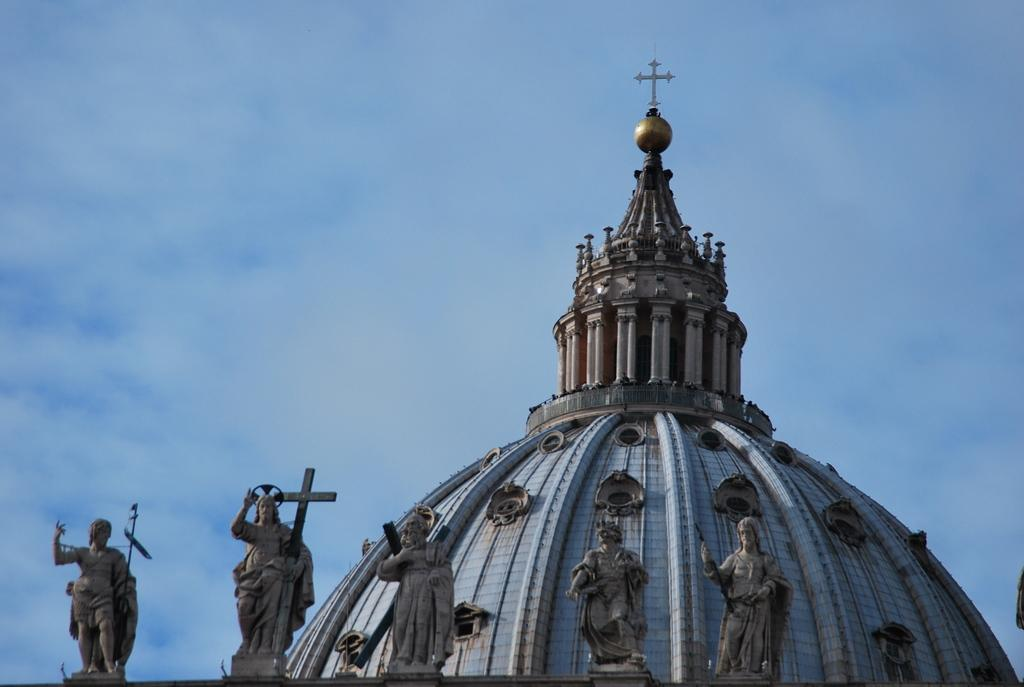What is the main subject of the image? The image shows the top of a building. What architectural features can be seen on the building? The building has pillars. Are there any decorative elements on the building? Yes, there are statues in the image. What can be seen in the background of the image? The sky is visible in the background. What is the weather like in the image? Clouds are present in the sky, suggesting a partly cloudy day. What type of pan is being used by the governor in the image? There is no governor or pan present in the image. What is the governor using the quill for in the image? There is no governor or quill present in the image. 